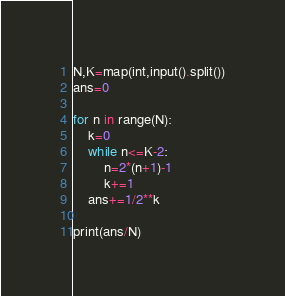<code> <loc_0><loc_0><loc_500><loc_500><_Python_>N,K=map(int,input().split())
ans=0

for n in range(N):
    k=0
    while n<=K-2:
        n=2*(n+1)-1
        k+=1
    ans+=1/2**k
        
print(ans/N)</code> 